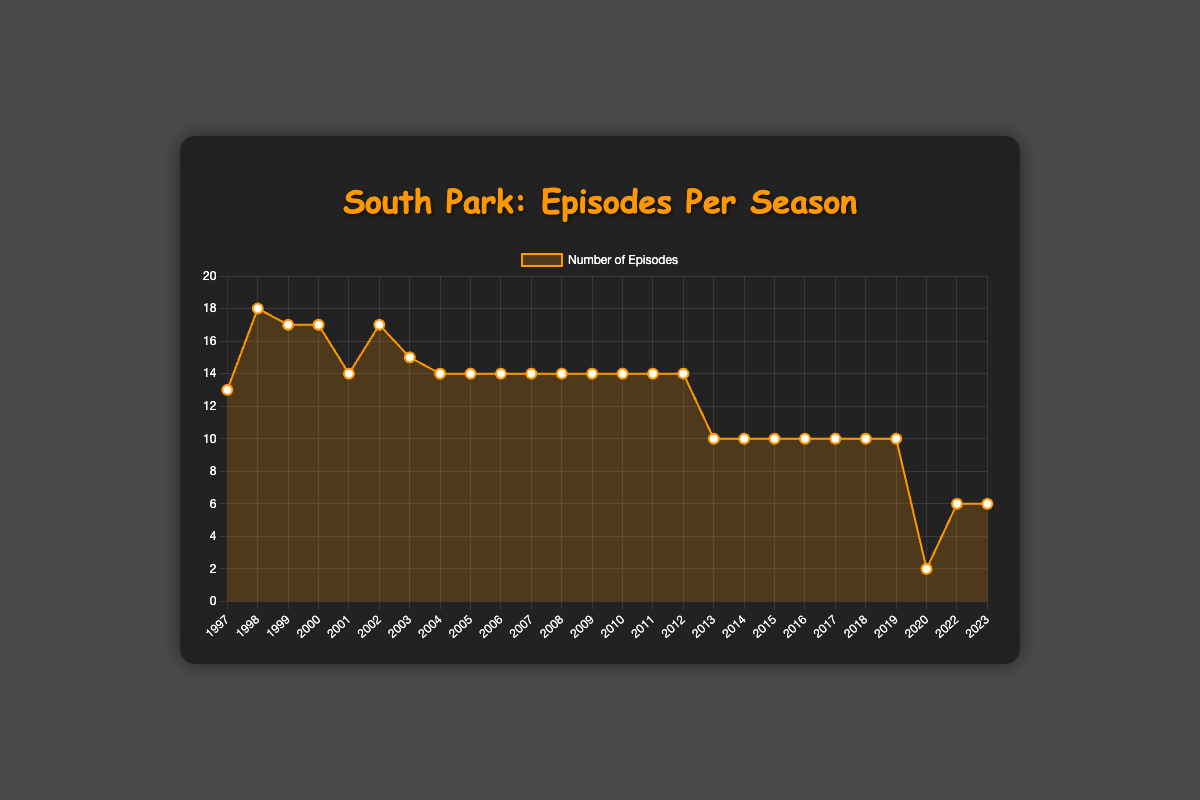What's the total number of episodes from Season 1 to Season 10? First, find the total number of episodes for each season from 1 to 10: (13 + 18 + 17 + 17 + 14 + 17 + 15 + 14 + 14 + 14). Adding these values together gives us the answer.
Answer: 153 Which season has the highest number of episodes? Look at the data points and find the season with the highest peak on the plot. The highest peak corresponds to Season 2 with 18 episodes.
Answer: Season 2 How many seasons have more than 15 episodes? Identify the seasons with episode counts greater than 15: Season 2 (18), Season 3 (17), Season 4 (17), and Season 6 (17). Count these seasons.
Answer: 4 How does the number of episodes in Season 24 compare to Season 25? Compare the points representing Season 24 and Season 25. Season 24 has 2 episodes, and Season 25 has 6 episodes. Season 25 has more episodes by 4.
Answer: Season 25 has 4 more episodes What is the average number of episodes per season from Season 17 to Season 26? Sum the number of episodes from Season 17 to Season 26: (10 + 10 + 10 + 10 + 10 + 10 + 2 + 6 + 6). Divide the sum by the number of seasons (10).
Answer: 8 Which period had a steady number of episodes per season, and how many episodes were there during that period? Look for a flat line in the plot, which indicates a steady number of episodes. Seasons 17 to 23 each had 10 episodes.
Answer: Seasons 17-23 with 10 episodes each What is the most significant drop in the number of episodes between any two consecutive seasons? Compare the number of episodes between each consecutive season and find the largest decrease. The most significant drop is from Season 23 (10 episodes) to Season 24 (2 episodes), a drop of 8 episodes.
Answer: 8 episodes What is the trend in the number of episodes from Season 1 to Season 26? Observe the overall progression of the line plot. Initially, episodes are high and then stabilize around 14 before gradually decreasing to 10 and reaching as low as 2 in recent seasons.
Answer: Decreasing trend What is the total number of episodes from Season 20 onwards? Sum the number of episodes from Season 20 to Season 26: (10 + 10 + 10 + 10 + 2 + 6 + 6).
Answer: 54 